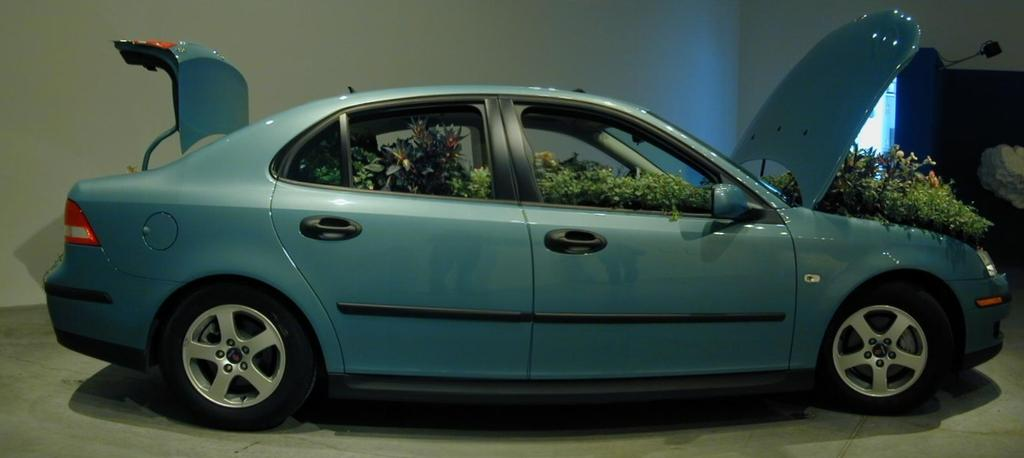What is the main subject of the image? There is a car in the image. What is unique about the interior of the car? There are plants inside the car. Can you describe the background of the image? There is another car, a window, and a light with a stand in the background of the image. What part of the car is responsible for the northward movement of the vehicle? There is no mention of the car moving in any direction in the image, nor is there any indication of a specific part responsible for northward movement. 